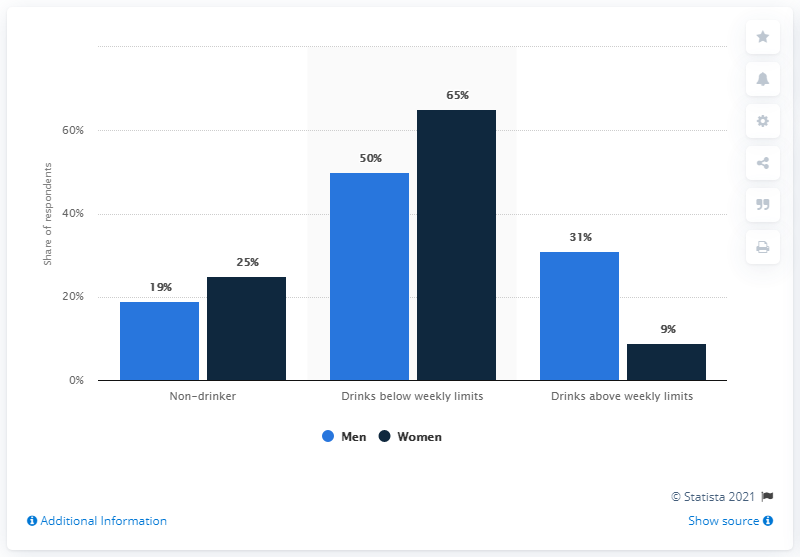Outline some significant characteristics in this image. According to the provided data, it can be stated that approximately 25% of women and 19% of men did not consume alcohol. 